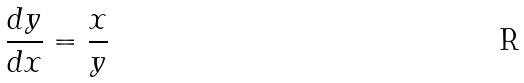<formula> <loc_0><loc_0><loc_500><loc_500>\frac { d y } { d x } = \frac { x } { y }</formula> 